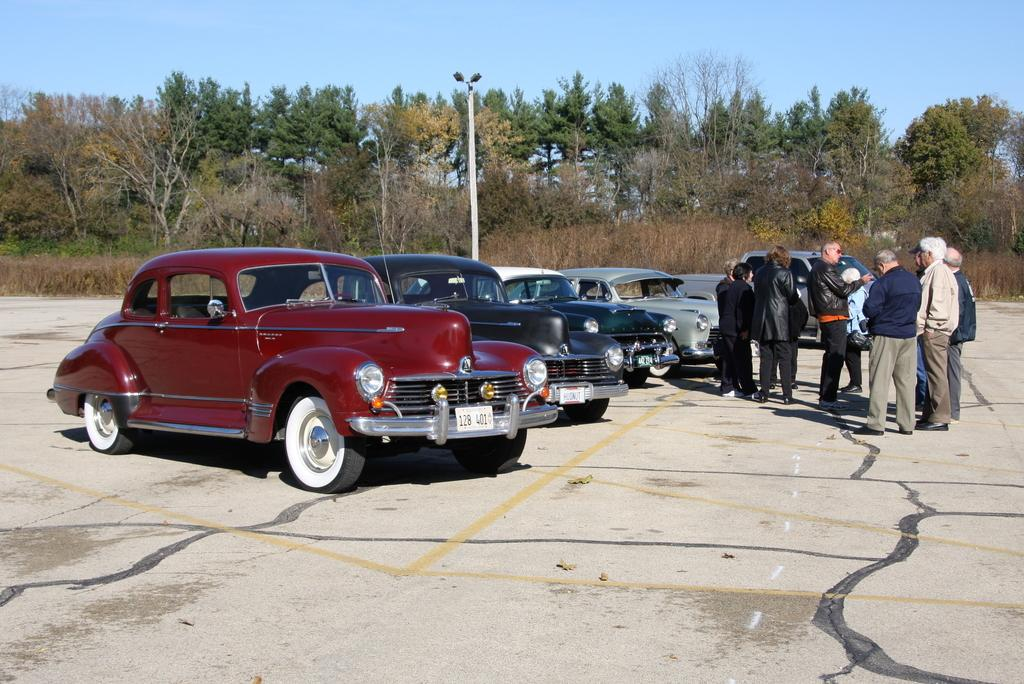How many cars are present in the image? There are 5 cars in the image. What else can be seen in the image besides the cars? There are people standing in the image, and there is a path visible. What is in the background of the image? In the background of the image, there is a pole, plants, trees, and the sky. What type of advertisement can be seen on the cars in the image? There is no advertisement visible on the cars in the image. What topic are the people discussing in the image? There is no indication of a discussion taking place in the image. 